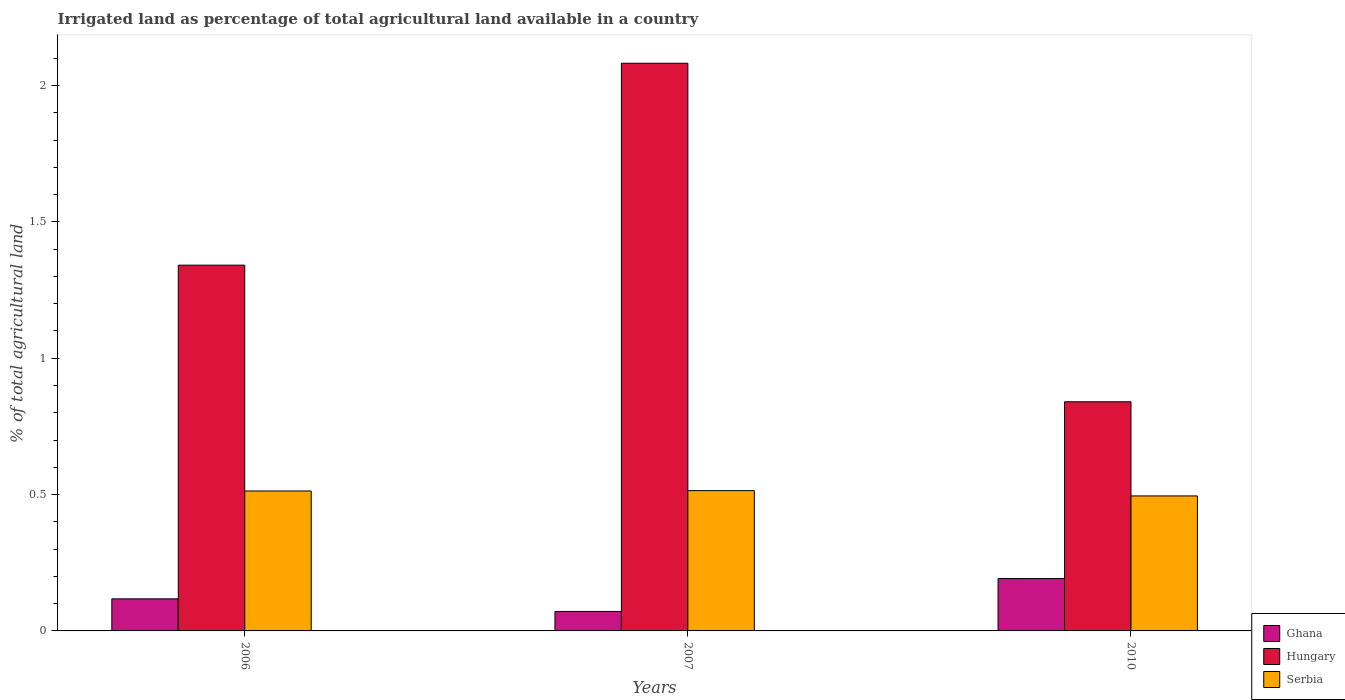How many different coloured bars are there?
Your response must be concise. 3. How many groups of bars are there?
Provide a succinct answer. 3. How many bars are there on the 1st tick from the left?
Your answer should be compact. 3. What is the label of the 1st group of bars from the left?
Your answer should be compact. 2006. What is the percentage of irrigated land in Hungary in 2006?
Your answer should be very brief. 1.34. Across all years, what is the maximum percentage of irrigated land in Hungary?
Your answer should be very brief. 2.08. Across all years, what is the minimum percentage of irrigated land in Serbia?
Your answer should be compact. 0.5. What is the total percentage of irrigated land in Serbia in the graph?
Your answer should be compact. 1.52. What is the difference between the percentage of irrigated land in Ghana in 2007 and that in 2010?
Provide a short and direct response. -0.12. What is the difference between the percentage of irrigated land in Hungary in 2007 and the percentage of irrigated land in Serbia in 2010?
Provide a succinct answer. 1.59. What is the average percentage of irrigated land in Ghana per year?
Keep it short and to the point. 0.13. In the year 2007, what is the difference between the percentage of irrigated land in Ghana and percentage of irrigated land in Hungary?
Your response must be concise. -2.01. In how many years, is the percentage of irrigated land in Serbia greater than 2 %?
Provide a short and direct response. 0. What is the ratio of the percentage of irrigated land in Serbia in 2006 to that in 2007?
Your answer should be compact. 1. Is the percentage of irrigated land in Hungary in 2006 less than that in 2007?
Give a very brief answer. Yes. Is the difference between the percentage of irrigated land in Ghana in 2006 and 2007 greater than the difference between the percentage of irrigated land in Hungary in 2006 and 2007?
Give a very brief answer. Yes. What is the difference between the highest and the second highest percentage of irrigated land in Ghana?
Your answer should be compact. 0.07. What is the difference between the highest and the lowest percentage of irrigated land in Ghana?
Give a very brief answer. 0.12. Is the sum of the percentage of irrigated land in Serbia in 2007 and 2010 greater than the maximum percentage of irrigated land in Hungary across all years?
Ensure brevity in your answer.  No. What does the 3rd bar from the left in 2007 represents?
Your answer should be compact. Serbia. What does the 3rd bar from the right in 2007 represents?
Offer a very short reply. Ghana. Are all the bars in the graph horizontal?
Your answer should be very brief. No. How many years are there in the graph?
Provide a succinct answer. 3. What is the difference between two consecutive major ticks on the Y-axis?
Make the answer very short. 0.5. Does the graph contain grids?
Provide a short and direct response. No. Where does the legend appear in the graph?
Keep it short and to the point. Bottom right. How many legend labels are there?
Give a very brief answer. 3. What is the title of the graph?
Offer a terse response. Irrigated land as percentage of total agricultural land available in a country. Does "Middle income" appear as one of the legend labels in the graph?
Make the answer very short. No. What is the label or title of the X-axis?
Provide a short and direct response. Years. What is the label or title of the Y-axis?
Give a very brief answer. % of total agricultural land. What is the % of total agricultural land of Ghana in 2006?
Provide a short and direct response. 0.12. What is the % of total agricultural land in Hungary in 2006?
Provide a short and direct response. 1.34. What is the % of total agricultural land in Serbia in 2006?
Keep it short and to the point. 0.51. What is the % of total agricultural land of Ghana in 2007?
Your answer should be compact. 0.07. What is the % of total agricultural land of Hungary in 2007?
Provide a succinct answer. 2.08. What is the % of total agricultural land in Serbia in 2007?
Provide a succinct answer. 0.51. What is the % of total agricultural land in Ghana in 2010?
Provide a short and direct response. 0.19. What is the % of total agricultural land of Hungary in 2010?
Give a very brief answer. 0.84. What is the % of total agricultural land in Serbia in 2010?
Your response must be concise. 0.5. Across all years, what is the maximum % of total agricultural land in Ghana?
Your answer should be very brief. 0.19. Across all years, what is the maximum % of total agricultural land in Hungary?
Your answer should be compact. 2.08. Across all years, what is the maximum % of total agricultural land in Serbia?
Offer a very short reply. 0.51. Across all years, what is the minimum % of total agricultural land in Ghana?
Keep it short and to the point. 0.07. Across all years, what is the minimum % of total agricultural land in Hungary?
Offer a terse response. 0.84. Across all years, what is the minimum % of total agricultural land of Serbia?
Your response must be concise. 0.5. What is the total % of total agricultural land in Ghana in the graph?
Offer a terse response. 0.38. What is the total % of total agricultural land of Hungary in the graph?
Provide a short and direct response. 4.26. What is the total % of total agricultural land of Serbia in the graph?
Provide a succinct answer. 1.52. What is the difference between the % of total agricultural land in Ghana in 2006 and that in 2007?
Your answer should be compact. 0.05. What is the difference between the % of total agricultural land of Hungary in 2006 and that in 2007?
Your answer should be very brief. -0.74. What is the difference between the % of total agricultural land in Serbia in 2006 and that in 2007?
Provide a succinct answer. -0. What is the difference between the % of total agricultural land of Ghana in 2006 and that in 2010?
Keep it short and to the point. -0.07. What is the difference between the % of total agricultural land of Hungary in 2006 and that in 2010?
Your answer should be compact. 0.5. What is the difference between the % of total agricultural land in Serbia in 2006 and that in 2010?
Provide a short and direct response. 0.02. What is the difference between the % of total agricultural land of Ghana in 2007 and that in 2010?
Ensure brevity in your answer.  -0.12. What is the difference between the % of total agricultural land of Hungary in 2007 and that in 2010?
Make the answer very short. 1.24. What is the difference between the % of total agricultural land in Serbia in 2007 and that in 2010?
Provide a short and direct response. 0.02. What is the difference between the % of total agricultural land in Ghana in 2006 and the % of total agricultural land in Hungary in 2007?
Make the answer very short. -1.96. What is the difference between the % of total agricultural land in Ghana in 2006 and the % of total agricultural land in Serbia in 2007?
Make the answer very short. -0.4. What is the difference between the % of total agricultural land in Hungary in 2006 and the % of total agricultural land in Serbia in 2007?
Offer a very short reply. 0.83. What is the difference between the % of total agricultural land in Ghana in 2006 and the % of total agricultural land in Hungary in 2010?
Offer a terse response. -0.72. What is the difference between the % of total agricultural land of Ghana in 2006 and the % of total agricultural land of Serbia in 2010?
Offer a terse response. -0.38. What is the difference between the % of total agricultural land of Hungary in 2006 and the % of total agricultural land of Serbia in 2010?
Your answer should be compact. 0.85. What is the difference between the % of total agricultural land in Ghana in 2007 and the % of total agricultural land in Hungary in 2010?
Provide a short and direct response. -0.77. What is the difference between the % of total agricultural land in Ghana in 2007 and the % of total agricultural land in Serbia in 2010?
Provide a short and direct response. -0.42. What is the difference between the % of total agricultural land of Hungary in 2007 and the % of total agricultural land of Serbia in 2010?
Provide a short and direct response. 1.59. What is the average % of total agricultural land in Ghana per year?
Offer a terse response. 0.13. What is the average % of total agricultural land of Hungary per year?
Provide a short and direct response. 1.42. What is the average % of total agricultural land in Serbia per year?
Your response must be concise. 0.51. In the year 2006, what is the difference between the % of total agricultural land in Ghana and % of total agricultural land in Hungary?
Make the answer very short. -1.22. In the year 2006, what is the difference between the % of total agricultural land of Ghana and % of total agricultural land of Serbia?
Provide a succinct answer. -0.4. In the year 2006, what is the difference between the % of total agricultural land in Hungary and % of total agricultural land in Serbia?
Provide a short and direct response. 0.83. In the year 2007, what is the difference between the % of total agricultural land in Ghana and % of total agricultural land in Hungary?
Offer a very short reply. -2.01. In the year 2007, what is the difference between the % of total agricultural land of Ghana and % of total agricultural land of Serbia?
Provide a short and direct response. -0.44. In the year 2007, what is the difference between the % of total agricultural land in Hungary and % of total agricultural land in Serbia?
Make the answer very short. 1.57. In the year 2010, what is the difference between the % of total agricultural land in Ghana and % of total agricultural land in Hungary?
Give a very brief answer. -0.65. In the year 2010, what is the difference between the % of total agricultural land in Ghana and % of total agricultural land in Serbia?
Offer a very short reply. -0.3. In the year 2010, what is the difference between the % of total agricultural land in Hungary and % of total agricultural land in Serbia?
Give a very brief answer. 0.35. What is the ratio of the % of total agricultural land in Ghana in 2006 to that in 2007?
Provide a short and direct response. 1.65. What is the ratio of the % of total agricultural land in Hungary in 2006 to that in 2007?
Provide a short and direct response. 0.64. What is the ratio of the % of total agricultural land of Serbia in 2006 to that in 2007?
Ensure brevity in your answer.  1. What is the ratio of the % of total agricultural land of Ghana in 2006 to that in 2010?
Your response must be concise. 0.61. What is the ratio of the % of total agricultural land of Hungary in 2006 to that in 2010?
Provide a succinct answer. 1.6. What is the ratio of the % of total agricultural land in Serbia in 2006 to that in 2010?
Provide a succinct answer. 1.04. What is the ratio of the % of total agricultural land of Ghana in 2007 to that in 2010?
Give a very brief answer. 0.37. What is the ratio of the % of total agricultural land in Hungary in 2007 to that in 2010?
Provide a short and direct response. 2.48. What is the ratio of the % of total agricultural land in Serbia in 2007 to that in 2010?
Your answer should be very brief. 1.04. What is the difference between the highest and the second highest % of total agricultural land in Ghana?
Keep it short and to the point. 0.07. What is the difference between the highest and the second highest % of total agricultural land of Hungary?
Provide a succinct answer. 0.74. What is the difference between the highest and the second highest % of total agricultural land in Serbia?
Provide a succinct answer. 0. What is the difference between the highest and the lowest % of total agricultural land of Ghana?
Your response must be concise. 0.12. What is the difference between the highest and the lowest % of total agricultural land in Hungary?
Your response must be concise. 1.24. What is the difference between the highest and the lowest % of total agricultural land of Serbia?
Ensure brevity in your answer.  0.02. 